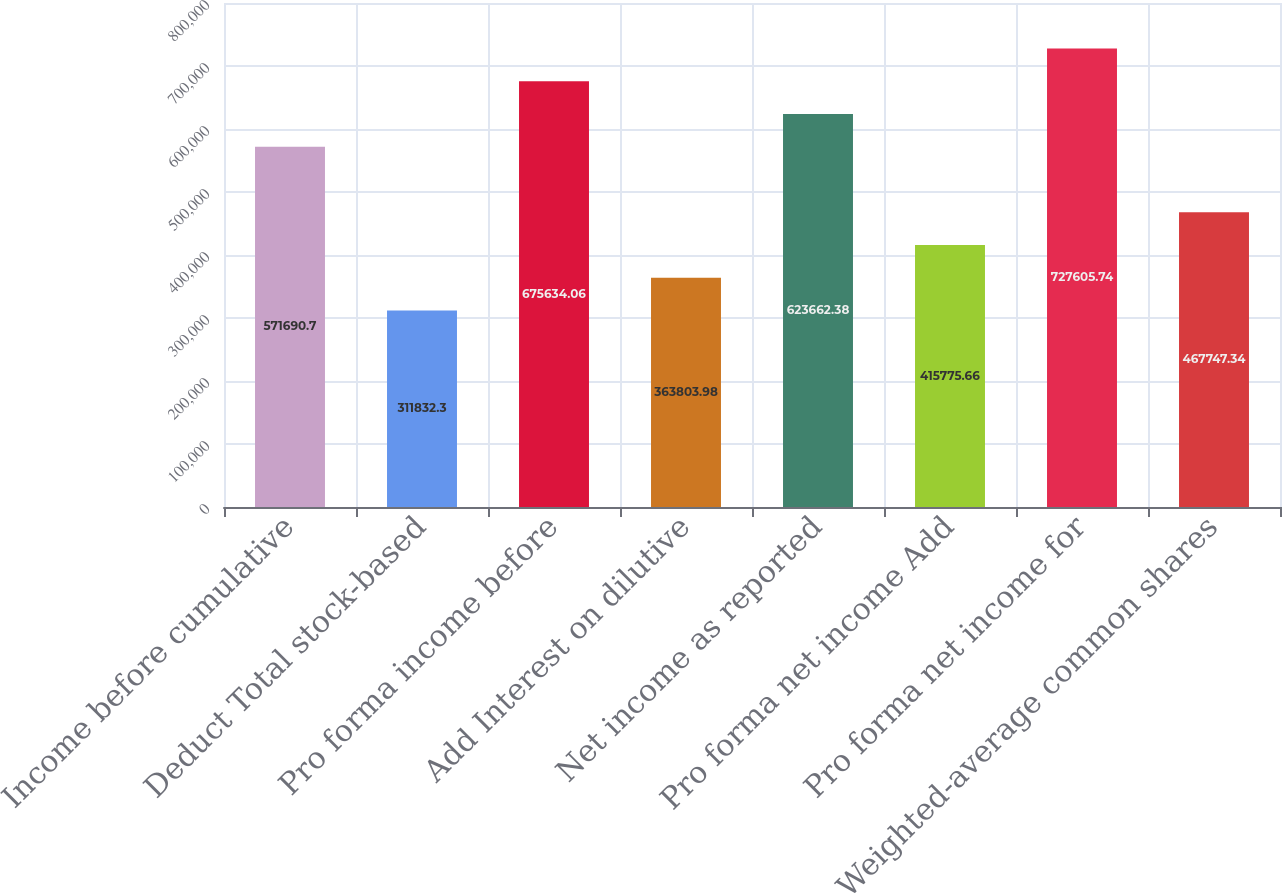Convert chart to OTSL. <chart><loc_0><loc_0><loc_500><loc_500><bar_chart><fcel>Income before cumulative<fcel>Deduct Total stock-based<fcel>Pro forma income before<fcel>Add Interest on dilutive<fcel>Net income as reported<fcel>Pro forma net income Add<fcel>Pro forma net income for<fcel>Weighted-average common shares<nl><fcel>571691<fcel>311832<fcel>675634<fcel>363804<fcel>623662<fcel>415776<fcel>727606<fcel>467747<nl></chart> 